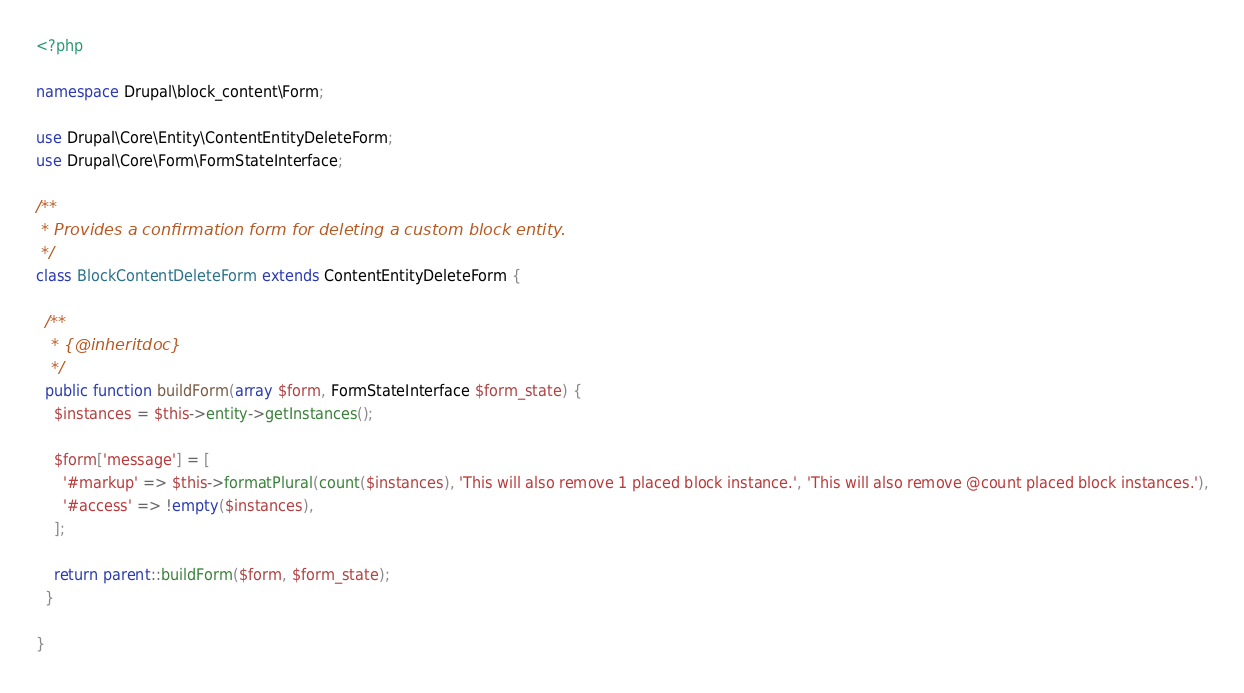<code> <loc_0><loc_0><loc_500><loc_500><_PHP_><?php

namespace Drupal\block_content\Form;

use Drupal\Core\Entity\ContentEntityDeleteForm;
use Drupal\Core\Form\FormStateInterface;

/**
 * Provides a confirmation form for deleting a custom block entity.
 */
class BlockContentDeleteForm extends ContentEntityDeleteForm {

  /**
   * {@inheritdoc}
   */
  public function buildForm(array $form, FormStateInterface $form_state) {
    $instances = $this->entity->getInstances();

    $form['message'] = [
      '#markup' => $this->formatPlural(count($instances), 'This will also remove 1 placed block instance.', 'This will also remove @count placed block instances.'),
      '#access' => !empty($instances),
    ];

    return parent::buildForm($form, $form_state);
  }

}
</code> 